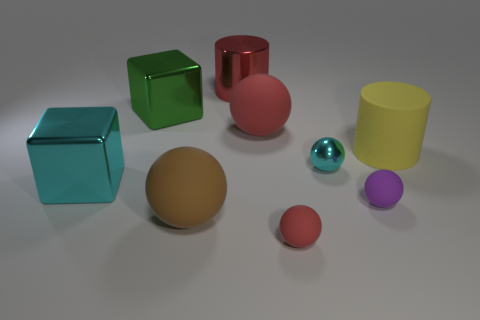There is a large shiny cylinder; is its color the same as the rubber ball that is behind the yellow object?
Your answer should be compact. Yes. There is a big metal object on the left side of the big green block; does it have the same shape as the big green object?
Provide a short and direct response. Yes. Is there a big metallic block of the same color as the tiny metal object?
Keep it short and to the point. Yes. What is the size of the purple object that is made of the same material as the big yellow cylinder?
Provide a succinct answer. Small. There is a cyan metal object that is the same shape as the purple object; what size is it?
Your response must be concise. Small. There is a sphere that is both in front of the yellow object and behind the big cyan object; how big is it?
Provide a succinct answer. Small. There is a metal thing that is the same color as the metal sphere; what shape is it?
Make the answer very short. Cube. What is the color of the shiny cylinder?
Your answer should be compact. Red. There is a red rubber object in front of the matte cylinder; what size is it?
Provide a succinct answer. Small. What number of purple rubber spheres are in front of the cyan object right of the big metallic block behind the big cyan metallic object?
Your answer should be compact. 1. 